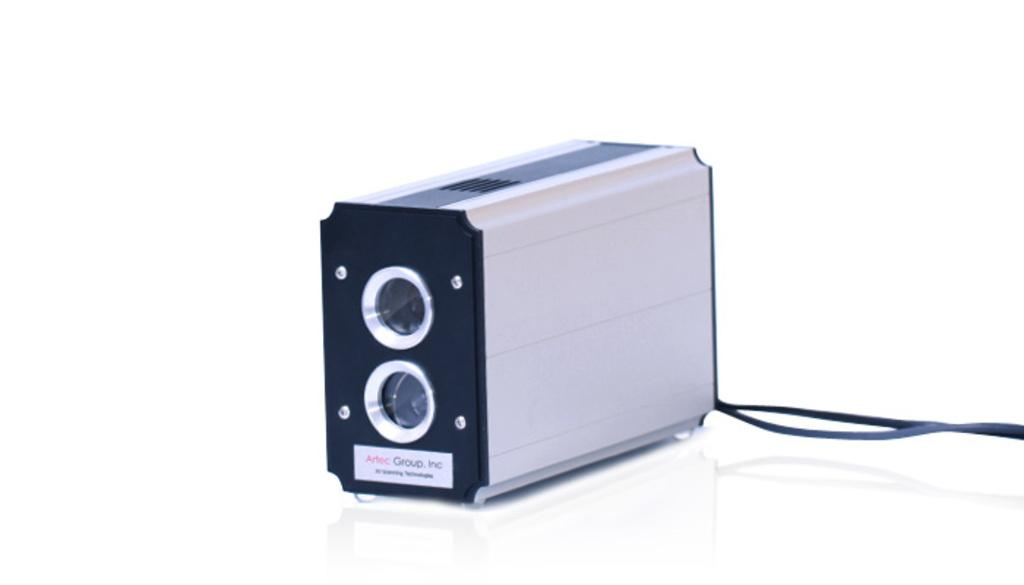What is there is a device with a black strap in the image, what is the device? The device with a black strap is not specified in the facts, but it is on a white surface. What is attached to the device? There is a sticky note on the device. What type of wilderness can be seen in the background of the image? There is no wilderness present in the image; it only shows a device with a black strap on a white surface and a sticky note on the device. 